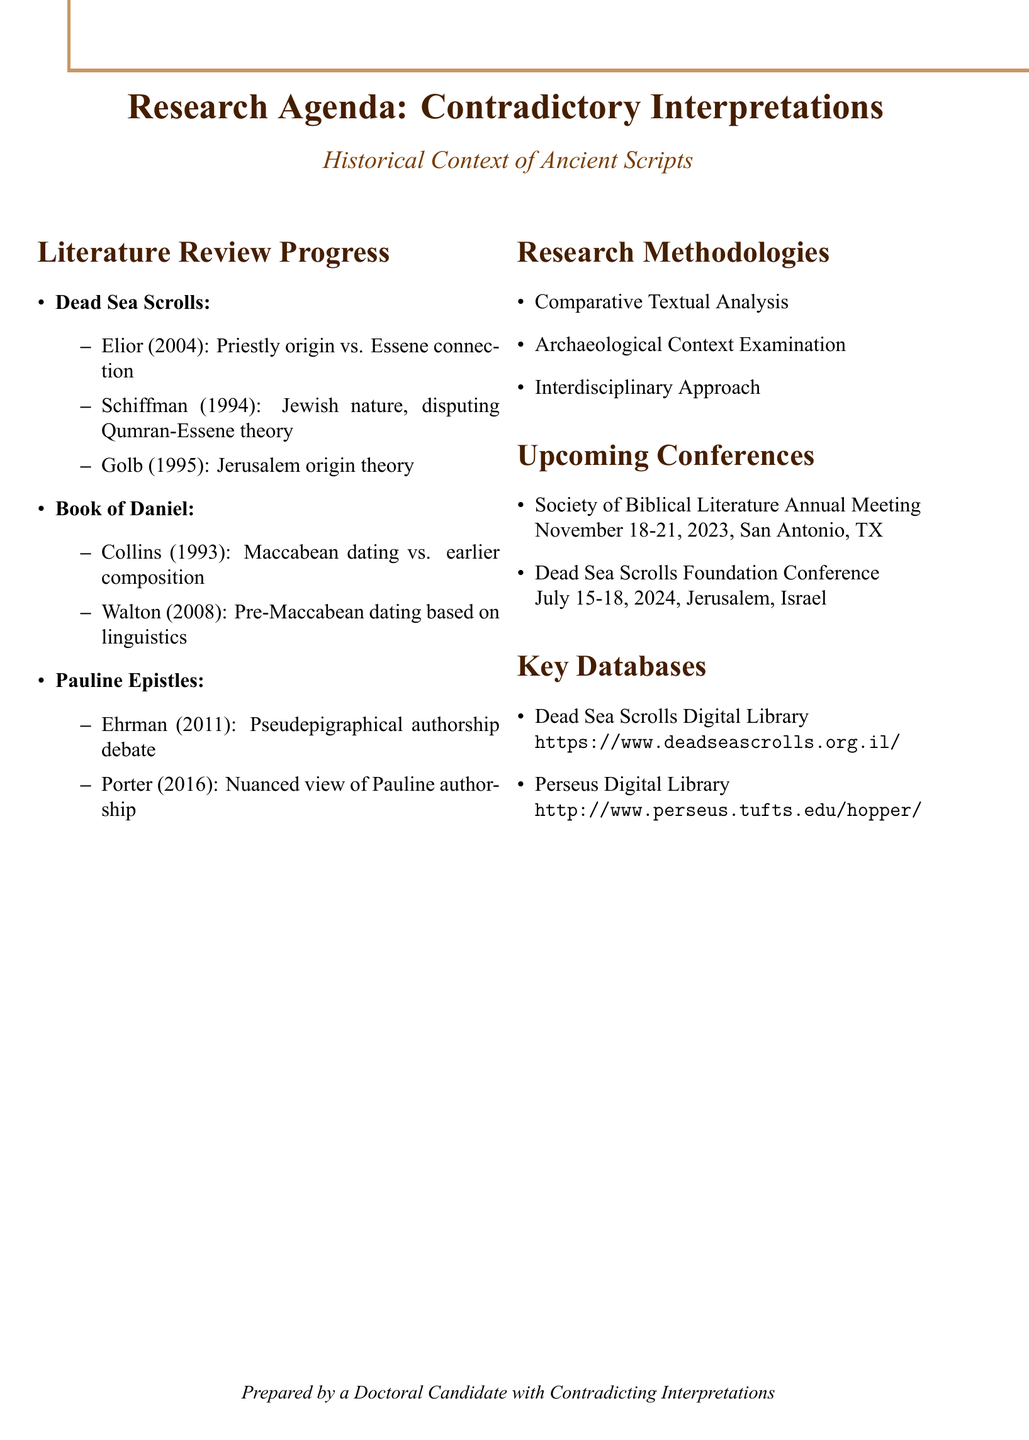What is the first source listed for the Dead Sea Scrolls? The first source under the Dead Sea Scrolls topic is Elior's work published in 2004.
Answer: Elior, Rachel What year was "Who Wrote the Dead Sea Scrolls?" published? The book "Who Wrote the Dead Sea Scrolls?" by Norman Golb was published in 1995.
Answer: 1995 What hypothesis does Collins support regarding the Book of Daniel? Collins supports the Maccabean dating hypothesis related to the Book of Daniel.
Answer: Maccabean dating hypothesis How many key methodologies are listed in the document? The document lists three key methodologies under research methodologies.
Answer: Three Which conference occurs first, the Society of Biblical Literature Annual Meeting or the Dead Sea Scrolls Foundation Conference? The Society of Biblical Literature Annual Meeting takes place from November 18-21, 2023, before the other conference.
Answer: Society of Biblical Literature Annual Meeting What is the website for the Dead Sea Scrolls Digital Library? The document provides the link for the Dead Sea Scrolls Digital Library.
Answer: https://www.deadseascrolls.org.il/ Which author proposed a nuanced view of Pauline authorship? The author mentioned for proposing a nuanced view of Pauline authorship is Stanley E. Porter.
Answer: Porter, Stanley E 